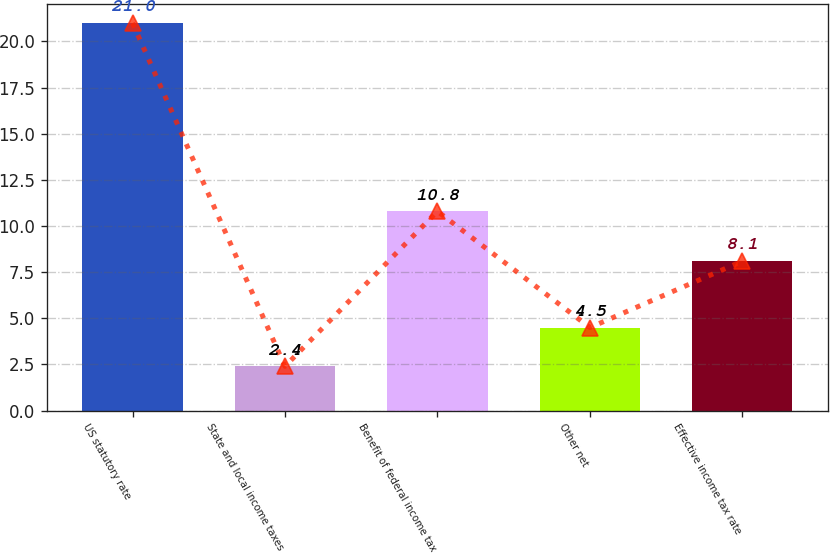<chart> <loc_0><loc_0><loc_500><loc_500><bar_chart><fcel>US statutory rate<fcel>State and local income taxes<fcel>Benefit of federal income tax<fcel>Other net<fcel>Effective income tax rate<nl><fcel>21<fcel>2.4<fcel>10.8<fcel>4.5<fcel>8.1<nl></chart> 